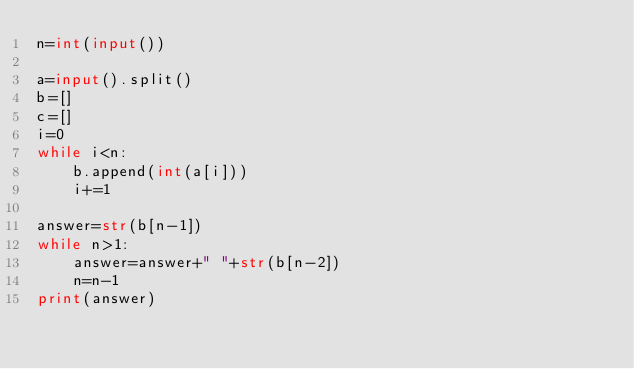Convert code to text. <code><loc_0><loc_0><loc_500><loc_500><_Python_>n=int(input())

a=input().split()
b=[]
c=[]
i=0
while i<n:
    b.append(int(a[i]))
    i+=1

answer=str(b[n-1])
while n>1:
    answer=answer+" "+str(b[n-2])
    n=n-1
print(answer)

</code> 